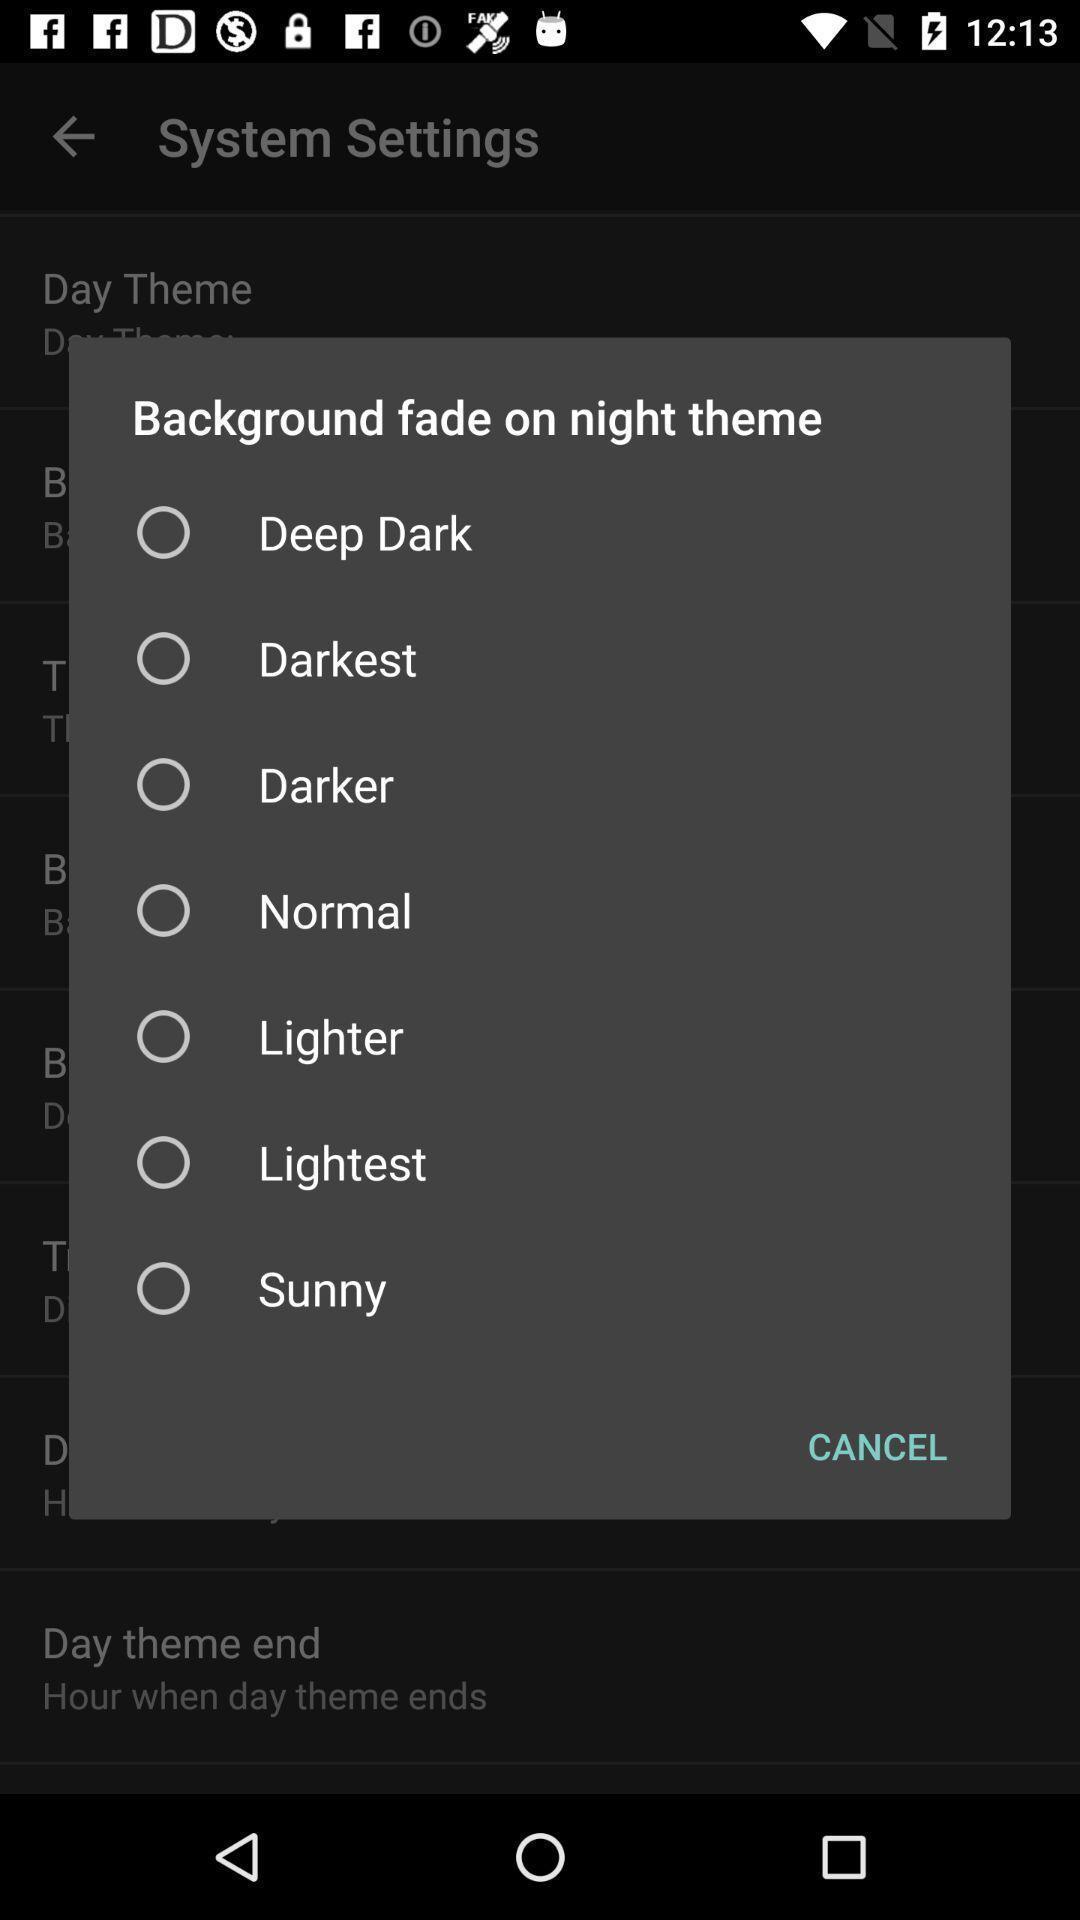What is the overall content of this screenshot? Popup to choose a theme in the application. 